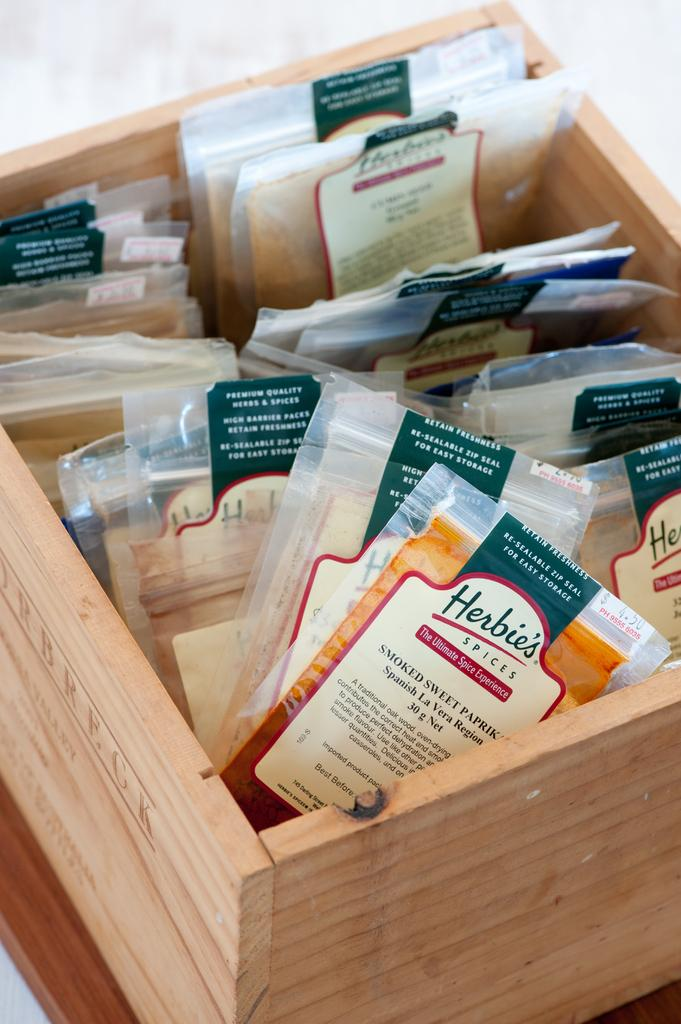Provide a one-sentence caption for the provided image. A wooden box of several spices from Herbie's. 